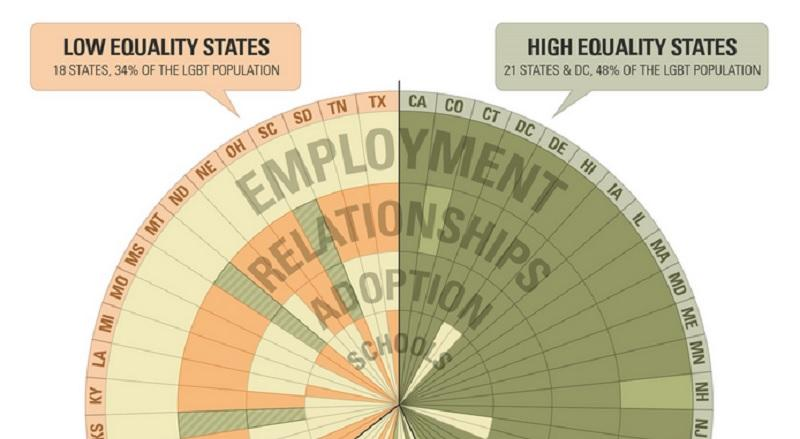Highlight a few significant elements in this photo. According to a recent survey, in states with low equality for the LGBT population, 34% of the population identifies as LGBT. Twenty-one states are considered high equality states. Is the state of DE a low equality state or a high equality state? The answer is a high equality state. The state of Louisiana is generally considered to be a low equality state. New Jersey is a state that prioritizes equality, with a focus on promoting high equality. 